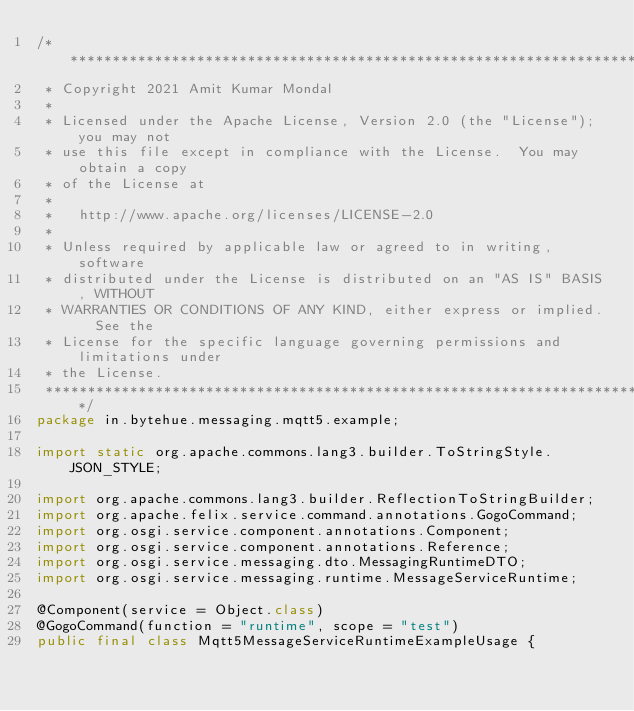Convert code to text. <code><loc_0><loc_0><loc_500><loc_500><_Java_>/*******************************************************************************
 * Copyright 2021 Amit Kumar Mondal
 *
 * Licensed under the Apache License, Version 2.0 (the "License"); you may not
 * use this file except in compliance with the License.  You may obtain a copy
 * of the License at
 *
 *   http://www.apache.org/licenses/LICENSE-2.0
 *
 * Unless required by applicable law or agreed to in writing, software
 * distributed under the License is distributed on an "AS IS" BASIS, WITHOUT
 * WARRANTIES OR CONDITIONS OF ANY KIND, either express or implied.  See the
 * License for the specific language governing permissions and limitations under
 * the License.
 ******************************************************************************/
package in.bytehue.messaging.mqtt5.example;

import static org.apache.commons.lang3.builder.ToStringStyle.JSON_STYLE;

import org.apache.commons.lang3.builder.ReflectionToStringBuilder;
import org.apache.felix.service.command.annotations.GogoCommand;
import org.osgi.service.component.annotations.Component;
import org.osgi.service.component.annotations.Reference;
import org.osgi.service.messaging.dto.MessagingRuntimeDTO;
import org.osgi.service.messaging.runtime.MessageServiceRuntime;

@Component(service = Object.class)
@GogoCommand(function = "runtime", scope = "test")
public final class Mqtt5MessageServiceRuntimeExampleUsage {
</code> 